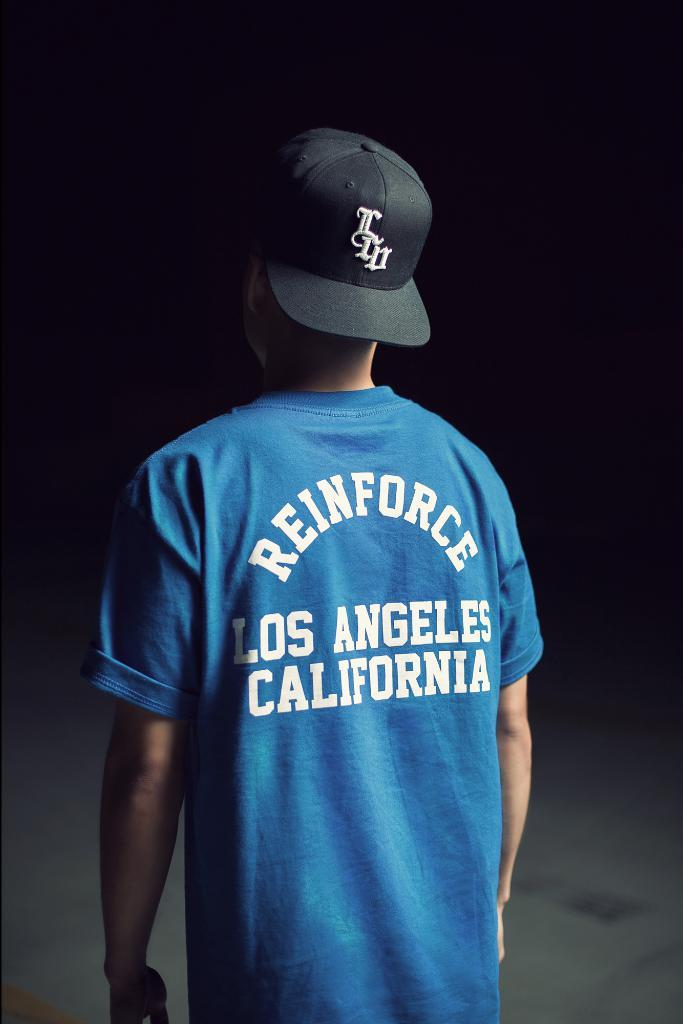<image>
Render a clear and concise summary of the photo. A blue tshirt with Reinforce Los Angeles California on it 